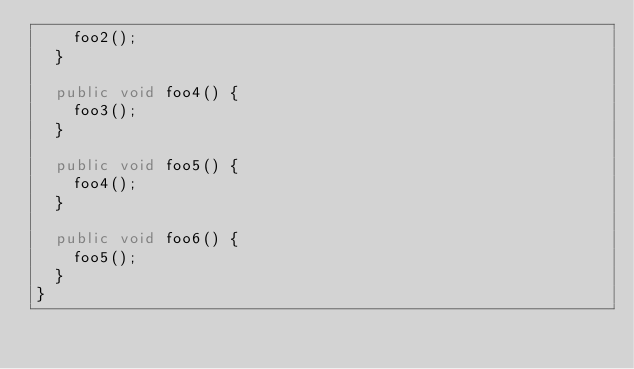<code> <loc_0><loc_0><loc_500><loc_500><_Java_>    foo2();
  }

  public void foo4() {
    foo3();
  }

  public void foo5() {
    foo4();
  }

  public void foo6() {
    foo5();
  }
}
</code> 